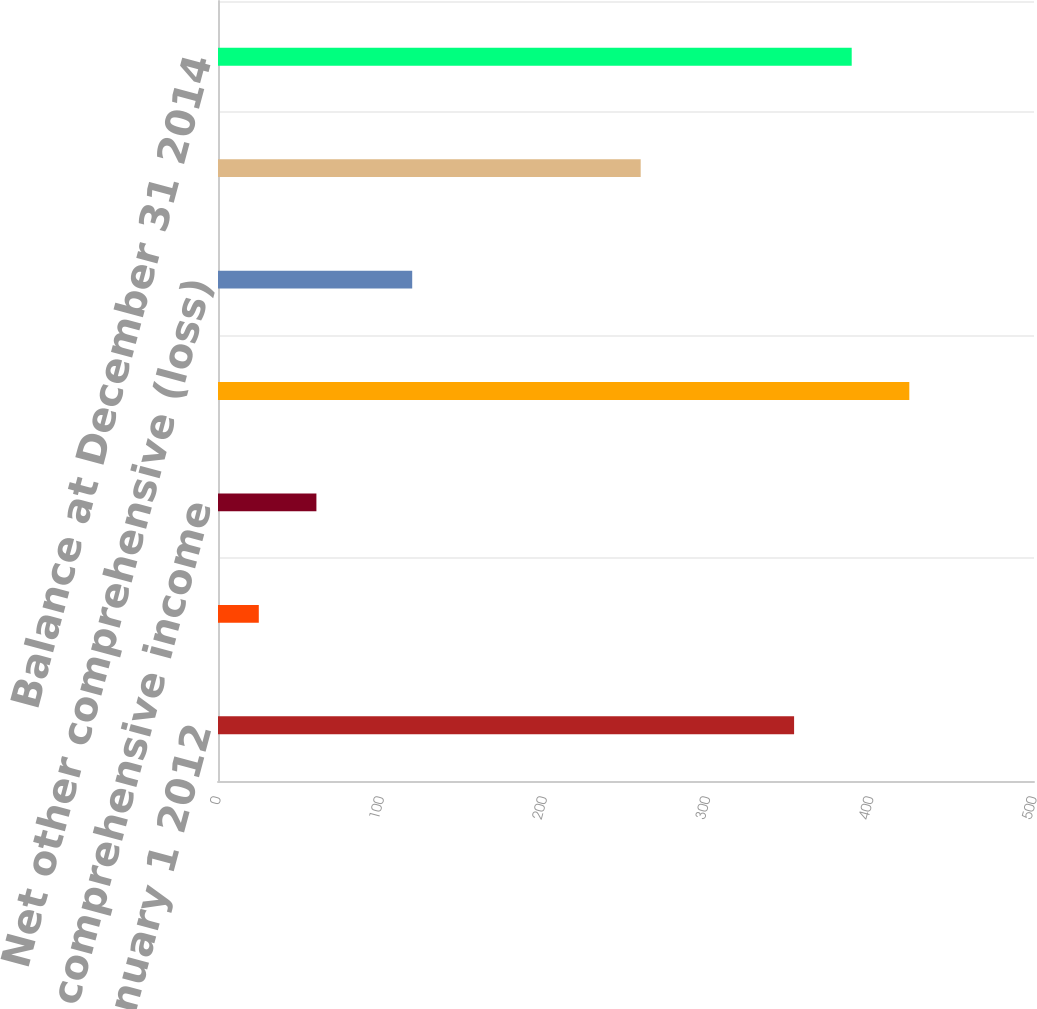Convert chart. <chart><loc_0><loc_0><loc_500><loc_500><bar_chart><fcel>Balance at January 1 2012<fcel>Amounts reclassified from<fcel>Net other comprehensive income<fcel>Balance at December 31 2012<fcel>Net other comprehensive (loss)<fcel>Balance at December 31 2013<fcel>Balance at December 31 2014<nl><fcel>353<fcel>25<fcel>60.3<fcel>423.6<fcel>119<fcel>259<fcel>388.3<nl></chart> 